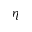Convert formula to latex. <formula><loc_0><loc_0><loc_500><loc_500>\eta</formula> 